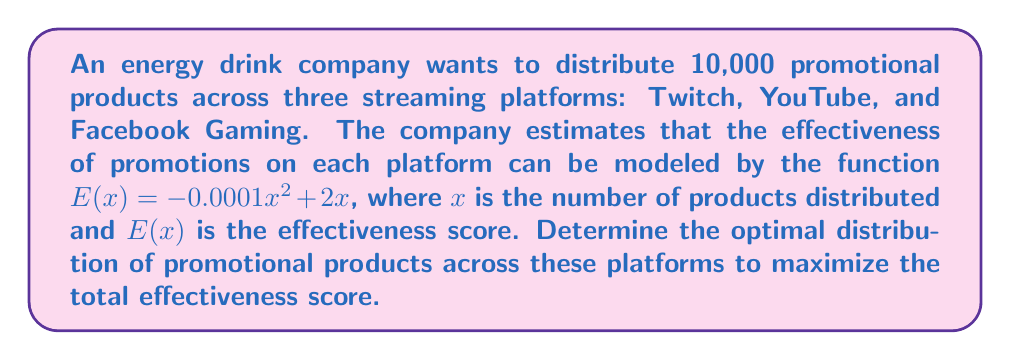Show me your answer to this math problem. 1. Let $x_1$, $x_2$, and $x_3$ represent the number of products distributed to Twitch, YouTube, and Facebook Gaming, respectively.

2. The total effectiveness score is the sum of individual platform scores:
   $$E_{total} = E(x_1) + E(x_2) + E(x_3)$$

3. We need to maximize $E_{total}$ subject to the constraint $x_1 + x_2 + x_3 = 10000$.

4. Since the effectiveness function is the same for all platforms, the maximum total effectiveness will occur when $E'(x_1) = E'(x_2) = E'(x_3)$.

5. Calculate the derivative of $E(x)$:
   $$E'(x) = -0.0002x + 2$$

6. Set the derivatives equal to each other:
   $$-0.0002x_1 + 2 = -0.0002x_2 + 2 = -0.0002x_3 + 2$$

7. This implies $x_1 = x_2 = x_3$.

8. Given the constraint $x_1 + x_2 + x_3 = 10000$, we can conclude:
   $$x_1 = x_2 = x_3 = \frac{10000}{3} \approx 3333.33$$

9. Since we can't distribute fractional products, we round to the nearest integer:
   $$x_1 = x_2 = x_3 = 3333$$

10. The remaining product can be distributed to any platform without significantly affecting the total effectiveness.
Answer: 3333 products to Twitch, 3333 to YouTube, 3334 to Facebook Gaming 